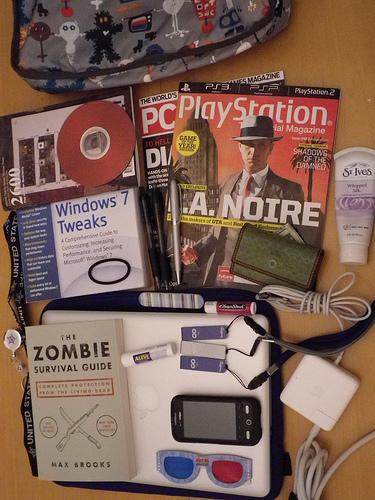Question: why are the lenses on the glasses red and blue?
Choices:
A. They are 3d glasses.
B. Reading glasses.
C. Corrective glasses.
D. Sunglasses.
Answer with the letter. Answer: A Question: what color is the st ives bottle?
Choices:
A. Blue.
B. Lavender.
C. Red.
D. Green.
Answer with the letter. Answer: B Question: where is the chapstick?
Choices:
A. Below the magazine.
B. On the table.
C. In the drawer.
D. On the chair.
Answer with the letter. Answer: A Question: what is the title of the book on the bottom left corner?
Choices:
A. The Jungle Guide.
B. Man with the Zombie.
C. Zombie Apocalypse.
D. THE ZOMBIE SURVIVAL GUIDE.
Answer with the letter. Answer: D Question: who is the author of the Zombie Survival Guide?
Choices:
A. Max Payne.
B. Frank Sinatra.
C. Max Brooks.
D. Michael Buble.
Answer with the letter. Answer: C Question: what color is the Zombie book?
Choices:
A. Red.
B. White.
C. Gray.
D. Blue.
Answer with the letter. Answer: C 